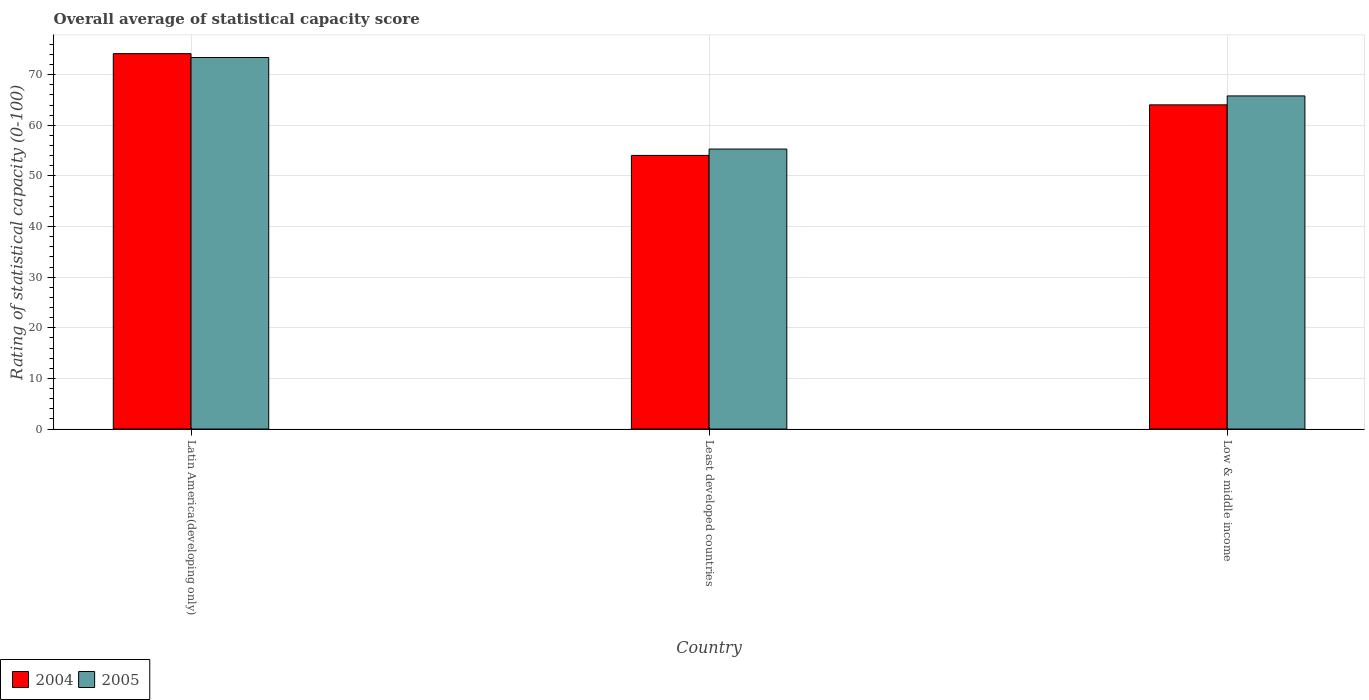How many groups of bars are there?
Provide a short and direct response. 3. Are the number of bars on each tick of the X-axis equal?
Give a very brief answer. Yes. How many bars are there on the 1st tick from the left?
Your answer should be very brief. 2. What is the label of the 3rd group of bars from the left?
Offer a very short reply. Low & middle income. What is the rating of statistical capacity in 2005 in Least developed countries?
Your answer should be compact. 55.32. Across all countries, what is the maximum rating of statistical capacity in 2004?
Your answer should be very brief. 74.17. Across all countries, what is the minimum rating of statistical capacity in 2004?
Provide a short and direct response. 54.05. In which country was the rating of statistical capacity in 2004 maximum?
Provide a short and direct response. Latin America(developing only). In which country was the rating of statistical capacity in 2004 minimum?
Your answer should be compact. Least developed countries. What is the total rating of statistical capacity in 2005 in the graph?
Offer a terse response. 194.53. What is the difference between the rating of statistical capacity in 2004 in Latin America(developing only) and that in Low & middle income?
Your answer should be compact. 10.12. What is the difference between the rating of statistical capacity in 2005 in Latin America(developing only) and the rating of statistical capacity in 2004 in Low & middle income?
Your answer should be compact. 9.35. What is the average rating of statistical capacity in 2004 per country?
Keep it short and to the point. 64.09. What is the difference between the rating of statistical capacity of/in 2005 and rating of statistical capacity of/in 2004 in Low & middle income?
Provide a succinct answer. 1.76. What is the ratio of the rating of statistical capacity in 2004 in Least developed countries to that in Low & middle income?
Provide a succinct answer. 0.84. Is the rating of statistical capacity in 2004 in Latin America(developing only) less than that in Low & middle income?
Offer a very short reply. No. Is the difference between the rating of statistical capacity in 2005 in Latin America(developing only) and Least developed countries greater than the difference between the rating of statistical capacity in 2004 in Latin America(developing only) and Least developed countries?
Offer a terse response. No. What is the difference between the highest and the second highest rating of statistical capacity in 2004?
Offer a terse response. -10.12. What is the difference between the highest and the lowest rating of statistical capacity in 2004?
Give a very brief answer. 20.11. What does the 2nd bar from the right in Least developed countries represents?
Your answer should be compact. 2004. How many bars are there?
Offer a terse response. 6. Are all the bars in the graph horizontal?
Offer a very short reply. No. Does the graph contain any zero values?
Provide a short and direct response. No. Does the graph contain grids?
Keep it short and to the point. Yes. How are the legend labels stacked?
Keep it short and to the point. Horizontal. What is the title of the graph?
Offer a terse response. Overall average of statistical capacity score. Does "1987" appear as one of the legend labels in the graph?
Ensure brevity in your answer.  No. What is the label or title of the X-axis?
Provide a succinct answer. Country. What is the label or title of the Y-axis?
Provide a succinct answer. Rating of statistical capacity (0-100). What is the Rating of statistical capacity (0-100) in 2004 in Latin America(developing only)?
Your answer should be very brief. 74.17. What is the Rating of statistical capacity (0-100) of 2005 in Latin America(developing only)?
Provide a short and direct response. 73.4. What is the Rating of statistical capacity (0-100) in 2004 in Least developed countries?
Give a very brief answer. 54.05. What is the Rating of statistical capacity (0-100) of 2005 in Least developed countries?
Offer a terse response. 55.32. What is the Rating of statistical capacity (0-100) in 2004 in Low & middle income?
Provide a short and direct response. 64.05. What is the Rating of statistical capacity (0-100) in 2005 in Low & middle income?
Make the answer very short. 65.81. Across all countries, what is the maximum Rating of statistical capacity (0-100) of 2004?
Make the answer very short. 74.17. Across all countries, what is the maximum Rating of statistical capacity (0-100) of 2005?
Give a very brief answer. 73.4. Across all countries, what is the minimum Rating of statistical capacity (0-100) in 2004?
Keep it short and to the point. 54.05. Across all countries, what is the minimum Rating of statistical capacity (0-100) of 2005?
Keep it short and to the point. 55.32. What is the total Rating of statistical capacity (0-100) of 2004 in the graph?
Your response must be concise. 192.27. What is the total Rating of statistical capacity (0-100) in 2005 in the graph?
Your answer should be compact. 194.53. What is the difference between the Rating of statistical capacity (0-100) of 2004 in Latin America(developing only) and that in Least developed countries?
Provide a succinct answer. 20.11. What is the difference between the Rating of statistical capacity (0-100) of 2005 in Latin America(developing only) and that in Least developed countries?
Offer a terse response. 18.09. What is the difference between the Rating of statistical capacity (0-100) of 2004 in Latin America(developing only) and that in Low & middle income?
Keep it short and to the point. 10.12. What is the difference between the Rating of statistical capacity (0-100) in 2005 in Latin America(developing only) and that in Low & middle income?
Ensure brevity in your answer.  7.59. What is the difference between the Rating of statistical capacity (0-100) in 2004 in Least developed countries and that in Low & middle income?
Keep it short and to the point. -10. What is the difference between the Rating of statistical capacity (0-100) of 2005 in Least developed countries and that in Low & middle income?
Provide a succinct answer. -10.5. What is the difference between the Rating of statistical capacity (0-100) of 2004 in Latin America(developing only) and the Rating of statistical capacity (0-100) of 2005 in Least developed countries?
Your answer should be very brief. 18.85. What is the difference between the Rating of statistical capacity (0-100) of 2004 in Latin America(developing only) and the Rating of statistical capacity (0-100) of 2005 in Low & middle income?
Offer a very short reply. 8.35. What is the difference between the Rating of statistical capacity (0-100) of 2004 in Least developed countries and the Rating of statistical capacity (0-100) of 2005 in Low & middle income?
Offer a very short reply. -11.76. What is the average Rating of statistical capacity (0-100) in 2004 per country?
Your answer should be very brief. 64.09. What is the average Rating of statistical capacity (0-100) in 2005 per country?
Ensure brevity in your answer.  64.84. What is the difference between the Rating of statistical capacity (0-100) of 2004 and Rating of statistical capacity (0-100) of 2005 in Latin America(developing only)?
Make the answer very short. 0.76. What is the difference between the Rating of statistical capacity (0-100) in 2004 and Rating of statistical capacity (0-100) in 2005 in Least developed countries?
Give a very brief answer. -1.26. What is the difference between the Rating of statistical capacity (0-100) in 2004 and Rating of statistical capacity (0-100) in 2005 in Low & middle income?
Offer a very short reply. -1.76. What is the ratio of the Rating of statistical capacity (0-100) in 2004 in Latin America(developing only) to that in Least developed countries?
Give a very brief answer. 1.37. What is the ratio of the Rating of statistical capacity (0-100) of 2005 in Latin America(developing only) to that in Least developed countries?
Your response must be concise. 1.33. What is the ratio of the Rating of statistical capacity (0-100) in 2004 in Latin America(developing only) to that in Low & middle income?
Offer a terse response. 1.16. What is the ratio of the Rating of statistical capacity (0-100) of 2005 in Latin America(developing only) to that in Low & middle income?
Offer a very short reply. 1.12. What is the ratio of the Rating of statistical capacity (0-100) of 2004 in Least developed countries to that in Low & middle income?
Make the answer very short. 0.84. What is the ratio of the Rating of statistical capacity (0-100) in 2005 in Least developed countries to that in Low & middle income?
Your response must be concise. 0.84. What is the difference between the highest and the second highest Rating of statistical capacity (0-100) in 2004?
Give a very brief answer. 10.12. What is the difference between the highest and the second highest Rating of statistical capacity (0-100) in 2005?
Offer a very short reply. 7.59. What is the difference between the highest and the lowest Rating of statistical capacity (0-100) of 2004?
Provide a short and direct response. 20.11. What is the difference between the highest and the lowest Rating of statistical capacity (0-100) of 2005?
Ensure brevity in your answer.  18.09. 